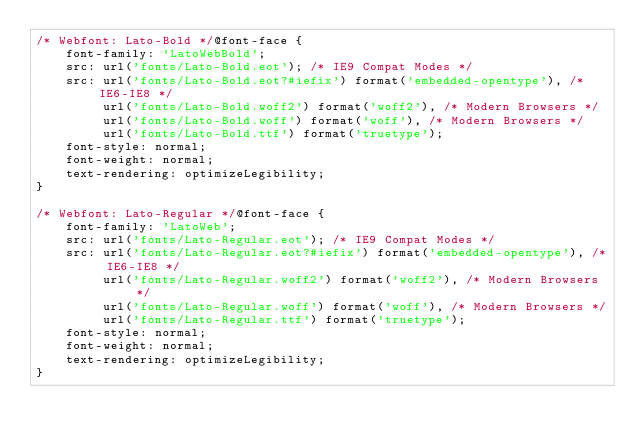<code> <loc_0><loc_0><loc_500><loc_500><_CSS_>/* Webfont: Lato-Bold */@font-face {
    font-family: 'LatoWebBold';
    src: url('fonts/Lato-Bold.eot'); /* IE9 Compat Modes */
    src: url('fonts/Lato-Bold.eot?#iefix') format('embedded-opentype'), /* IE6-IE8 */
         url('fonts/Lato-Bold.woff2') format('woff2'), /* Modern Browsers */
         url('fonts/Lato-Bold.woff') format('woff'), /* Modern Browsers */
         url('fonts/Lato-Bold.ttf') format('truetype');
    font-style: normal;
    font-weight: normal;
    text-rendering: optimizeLegibility;
}

/* Webfont: Lato-Regular */@font-face {
    font-family: 'LatoWeb';
    src: url('fonts/Lato-Regular.eot'); /* IE9 Compat Modes */
    src: url('fonts/Lato-Regular.eot?#iefix') format('embedded-opentype'), /* IE6-IE8 */
         url('fonts/Lato-Regular.woff2') format('woff2'), /* Modern Browsers */
         url('fonts/Lato-Regular.woff') format('woff'), /* Modern Browsers */
         url('fonts/Lato-Regular.ttf') format('truetype');
    font-style: normal;
    font-weight: normal;
    text-rendering: optimizeLegibility;
}</code> 